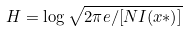<formula> <loc_0><loc_0><loc_500><loc_500>H = \log { \sqrt { 2 \pi e / [ N I ( x * ) ] } }</formula> 